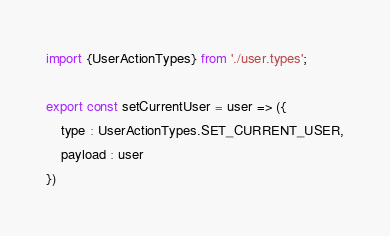Convert code to text. <code><loc_0><loc_0><loc_500><loc_500><_JavaScript_>import {UserActionTypes} from './user.types';

export const setCurrentUser = user => ({
    type : UserActionTypes.SET_CURRENT_USER,
    payload : user
})</code> 